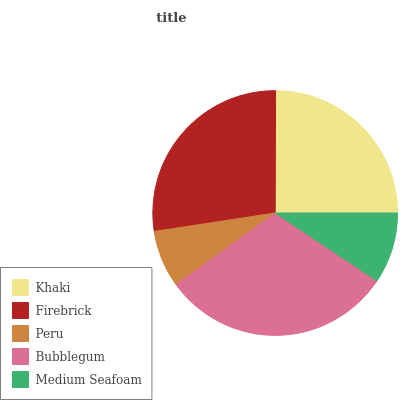Is Peru the minimum?
Answer yes or no. Yes. Is Bubblegum the maximum?
Answer yes or no. Yes. Is Firebrick the minimum?
Answer yes or no. No. Is Firebrick the maximum?
Answer yes or no. No. Is Firebrick greater than Khaki?
Answer yes or no. Yes. Is Khaki less than Firebrick?
Answer yes or no. Yes. Is Khaki greater than Firebrick?
Answer yes or no. No. Is Firebrick less than Khaki?
Answer yes or no. No. Is Khaki the high median?
Answer yes or no. Yes. Is Khaki the low median?
Answer yes or no. Yes. Is Peru the high median?
Answer yes or no. No. Is Medium Seafoam the low median?
Answer yes or no. No. 